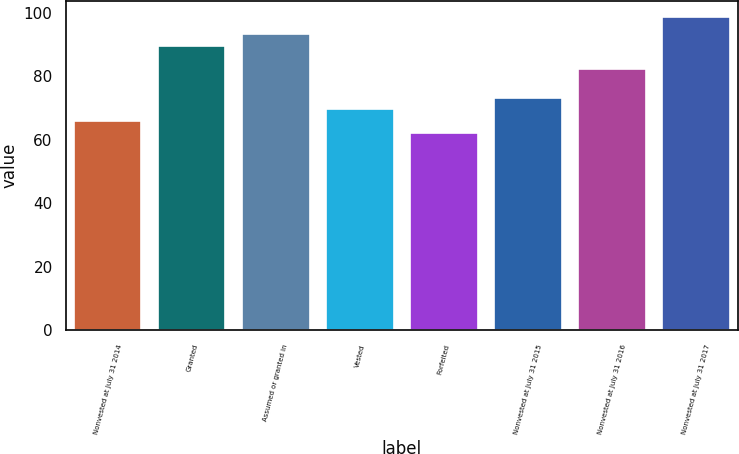Convert chart. <chart><loc_0><loc_0><loc_500><loc_500><bar_chart><fcel>Nonvested at July 31 2014<fcel>Granted<fcel>Assumed or granted in<fcel>Vested<fcel>Forfeited<fcel>Nonvested at July 31 2015<fcel>Nonvested at July 31 2016<fcel>Nonvested at July 31 2017<nl><fcel>65.96<fcel>89.58<fcel>93.22<fcel>69.6<fcel>62.32<fcel>73.24<fcel>82.3<fcel>98.76<nl></chart> 